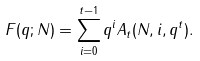Convert formula to latex. <formula><loc_0><loc_0><loc_500><loc_500>F ( q ; N ) = \sum _ { i = 0 } ^ { t - 1 } q ^ { i } A _ { t } ( N , i , q ^ { t } ) .</formula> 